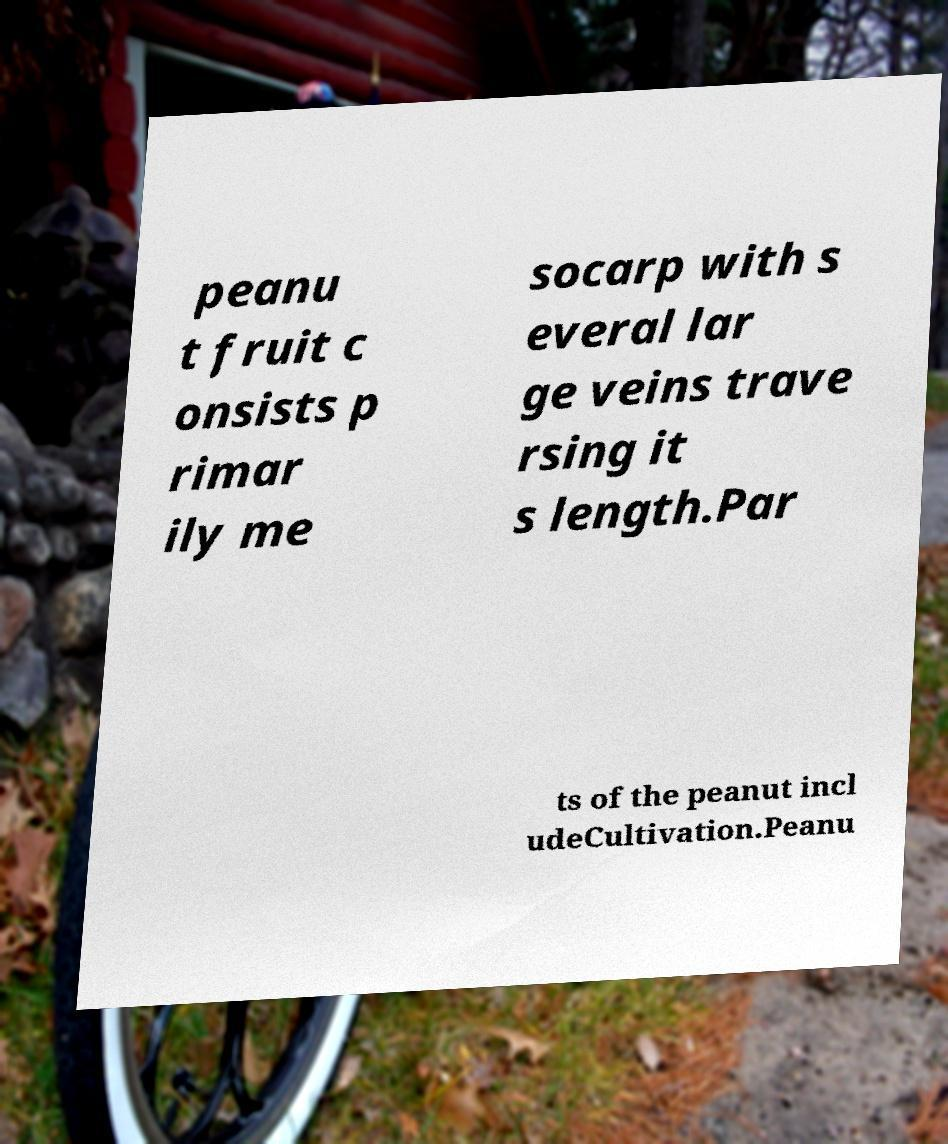There's text embedded in this image that I need extracted. Can you transcribe it verbatim? peanu t fruit c onsists p rimar ily me socarp with s everal lar ge veins trave rsing it s length.Par ts of the peanut incl udeCultivation.Peanu 